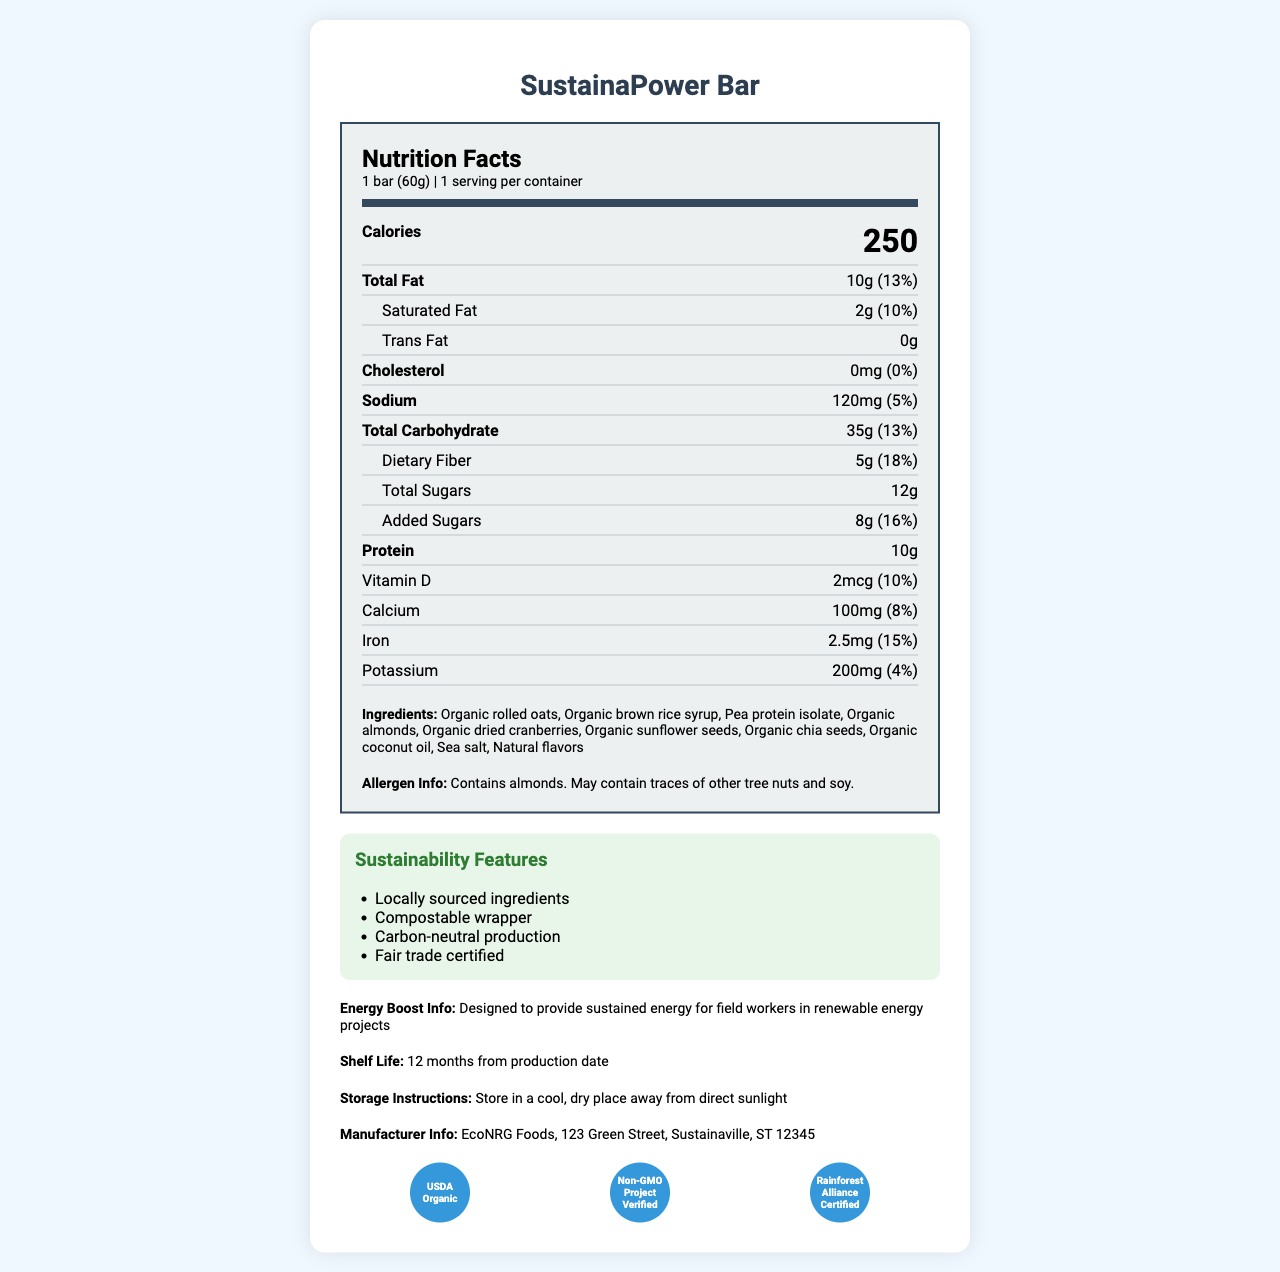what is the serving size of the SustainaPower Bar? The serving size is clearly indicated as "1 bar (60g)" in the nutrition label section.
Answer: 1 bar (60g) how many calories does a SustainaPower Bar contain? The "Calories" section explicitly states that one bar contains 250 calories.
Answer: 250 what percentage of daily value of dietary fiber does one bar provide? The dietary fiber content is listed as "5g" with a daily value of "18%."
Answer: 18% how much iron is present in one bar? The amount of iron is mentioned as "2.5mg" with a corresponding daily value of "15%."
Answer: 2.5mg what is the total amount of sugars in one bar? The "Total Sugars" section lists 12g of sugars.
Answer: 12g what certification is not mentioned for the SustainaPower Bar? A. USDA Organic B. Non-GMO Project Verified C. Fair Trade Certified D. Vegan The certifications listed are "USDA Organic," "Non-GMO Project Verified," and "Rainforest Alliance Certified," but "Vegan" is not mentioned.
Answer: D. Vegan what is the amount of sodium in one bar? 1. 100mg 2. 120mg 3. 80mg 4. 150mg The sodium content is indicated as 120mg.
Answer: 2. 120mg are the ingredients in the SustainaPower Bar locally sourced? One of the sustainability features is "Locally sourced ingredients."
Answer: Yes does the SustainaPower Bar contain any allergens? The allergen information states that the bar contains almonds and may contain traces of other tree nuts and soy.
Answer: Yes what certifications does the SustainaPower Bar have? The document lists "USDA Organic," "Non-GMO Project Verified," and "Rainforest Alliance Certified" as certifications.
Answer: USDA Organic, Non-GMO Project Verified, Rainforest Alliance Certified briefly describe the main idea of the SustainaPower Bar's nutrition label. The document provides detailed nutritional information about the SustainaPower Bar, including serving size, calories, macronutrients, allergens, and sustainability features. It emphasizes the bar's nutritional benefits and eco-friendly aspects, targeting field workers who need sustained energy.
Answer: The SustainaPower Bar is a nutritious and sustainable snack designed for field workers. It provides 250 calories per 60g serving, with significant amounts of protein and dietary fiber. The bar is made from organic ingredients and comes with several sustainability features and certifications, such as USDA Organic and Non-GMO Project Verified. where is the manufacturing facility of the SustainaPower Bar located? The manufacturer's information is provided at the end of the document, listing the address.
Answer: 123 Green Street, Sustainaville, ST 12345 how long is the shelf life of the SustainaPower Bar? The shelf life is explicitly mentioned as "12 months from production date."
Answer: 12 months from production date is the wrapper of the SustainaPower Bar compostable? One of the sustainability features listed is "Compostable wrapper."
Answer: Yes how much added sugar is in the SustainaPower Bar and what is its daily value percentage? The "Added Sugars" section lists 8g with a daily value of 16%.
Answer: 8g, 16% what is the primary source of protein in the SustainaPower Bar? Among the ingredients, "Pea protein isolate" is the most likely primary source of protein.
Answer: Pea protein isolate how is the SustainaPower Bar beneficial for field workers? The document states that the bar is designed to provide sustained energy for field workers in renewable energy projects.
Answer: Provides sustained energy what is the total carbohydrate count in one bar? The total carbohydrate content is listed as 35g.
Answer: 35g 